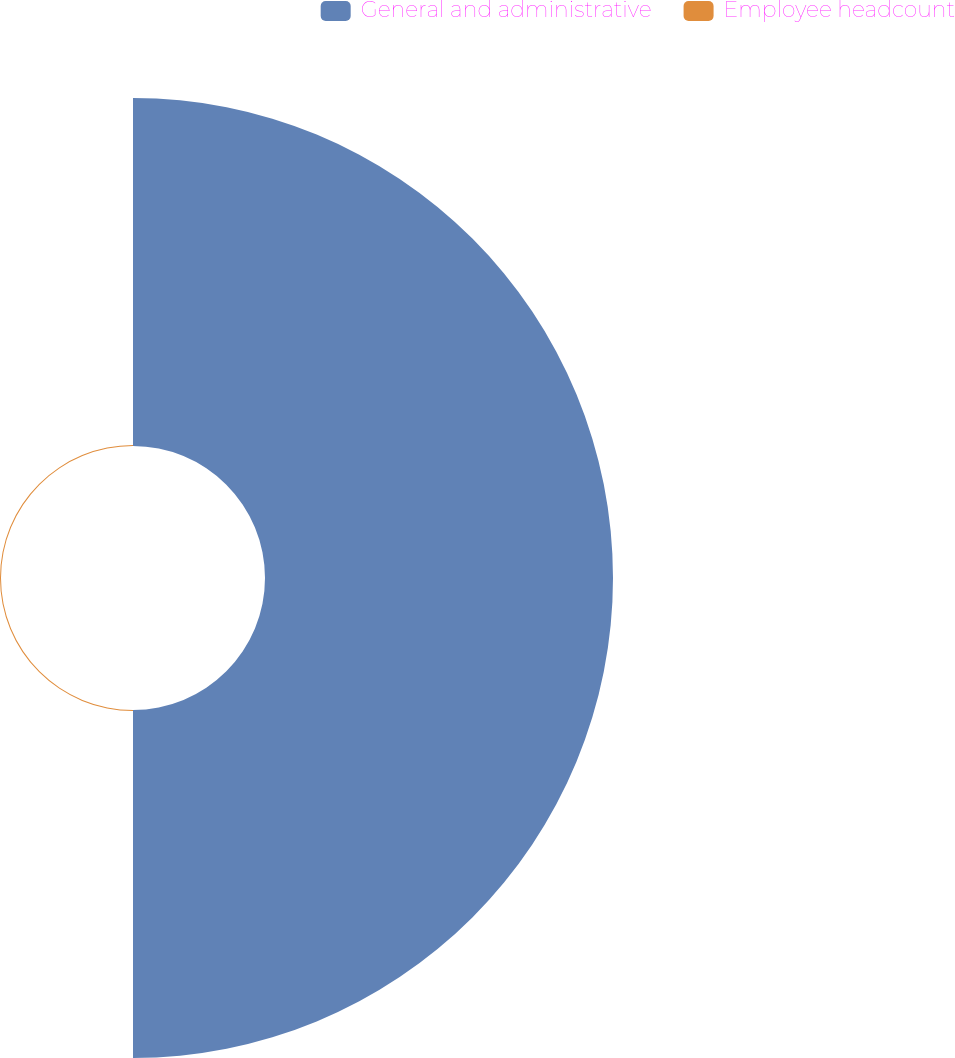Convert chart to OTSL. <chart><loc_0><loc_0><loc_500><loc_500><pie_chart><fcel>General and administrative<fcel>Employee headcount<nl><fcel>99.71%<fcel>0.29%<nl></chart> 